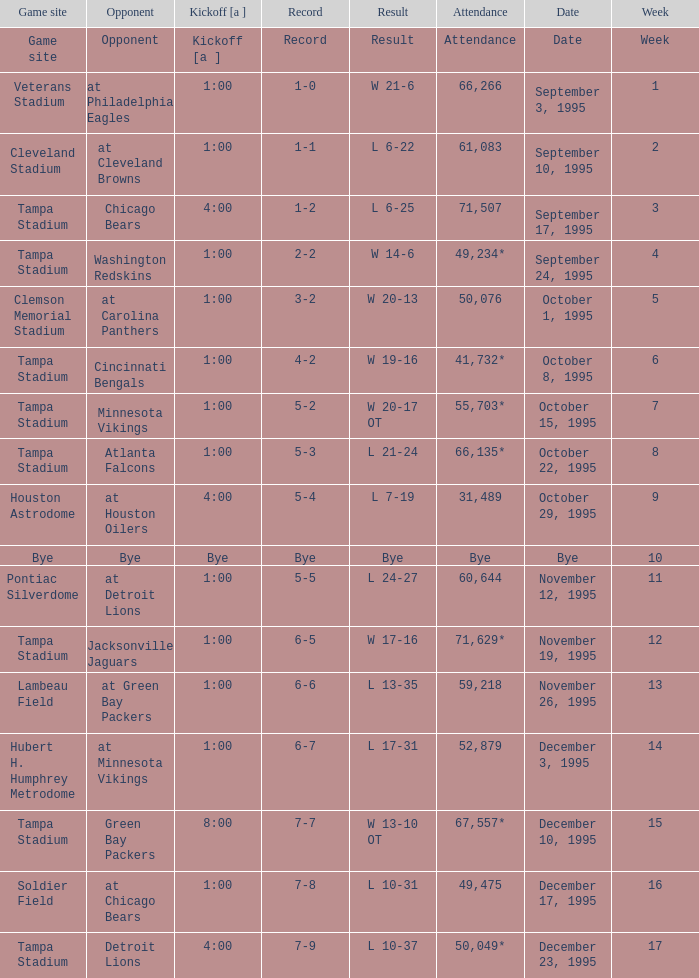Parse the full table. {'header': ['Game site', 'Opponent', 'Kickoff [a ]', 'Record', 'Result', 'Attendance', 'Date', 'Week'], 'rows': [['Game site', 'Opponent', 'Kickoff [a ]', 'Record', 'Result', 'Attendance', 'Date', 'Week'], ['Veterans Stadium', 'at Philadelphia Eagles', '1:00', '1-0', 'W 21-6', '66,266', 'September 3, 1995', '1'], ['Cleveland Stadium', 'at Cleveland Browns', '1:00', '1-1', 'L 6-22', '61,083', 'September 10, 1995', '2'], ['Tampa Stadium', 'Chicago Bears', '4:00', '1-2', 'L 6-25', '71,507', 'September 17, 1995', '3'], ['Tampa Stadium', 'Washington Redskins', '1:00', '2-2', 'W 14-6', '49,234*', 'September 24, 1995', '4'], ['Clemson Memorial Stadium', 'at Carolina Panthers', '1:00', '3-2', 'W 20-13', '50,076', 'October 1, 1995', '5'], ['Tampa Stadium', 'Cincinnati Bengals', '1:00', '4-2', 'W 19-16', '41,732*', 'October 8, 1995', '6'], ['Tampa Stadium', 'Minnesota Vikings', '1:00', '5-2', 'W 20-17 OT', '55,703*', 'October 15, 1995', '7'], ['Tampa Stadium', 'Atlanta Falcons', '1:00', '5-3', 'L 21-24', '66,135*', 'October 22, 1995', '8'], ['Houston Astrodome', 'at Houston Oilers', '4:00', '5-4', 'L 7-19', '31,489', 'October 29, 1995', '9'], ['Bye', 'Bye', 'Bye', 'Bye', 'Bye', 'Bye', 'Bye', '10'], ['Pontiac Silverdome', 'at Detroit Lions', '1:00', '5-5', 'L 24-27', '60,644', 'November 12, 1995', '11'], ['Tampa Stadium', 'Jacksonville Jaguars', '1:00', '6-5', 'W 17-16', '71,629*', 'November 19, 1995', '12'], ['Lambeau Field', 'at Green Bay Packers', '1:00', '6-6', 'L 13-35', '59,218', 'November 26, 1995', '13'], ['Hubert H. Humphrey Metrodome', 'at Minnesota Vikings', '1:00', '6-7', 'L 17-31', '52,879', 'December 3, 1995', '14'], ['Tampa Stadium', 'Green Bay Packers', '8:00', '7-7', 'W 13-10 OT', '67,557*', 'December 10, 1995', '15'], ['Soldier Field', 'at Chicago Bears', '1:00', '7-8', 'L 10-31', '49,475', 'December 17, 1995', '16'], ['Tampa Stadium', 'Detroit Lions', '4:00', '7-9', 'L 10-37', '50,049*', 'December 23, 1995', '17']]} Who did the Tampa Bay Buccaneers play on december 23, 1995? Detroit Lions. 